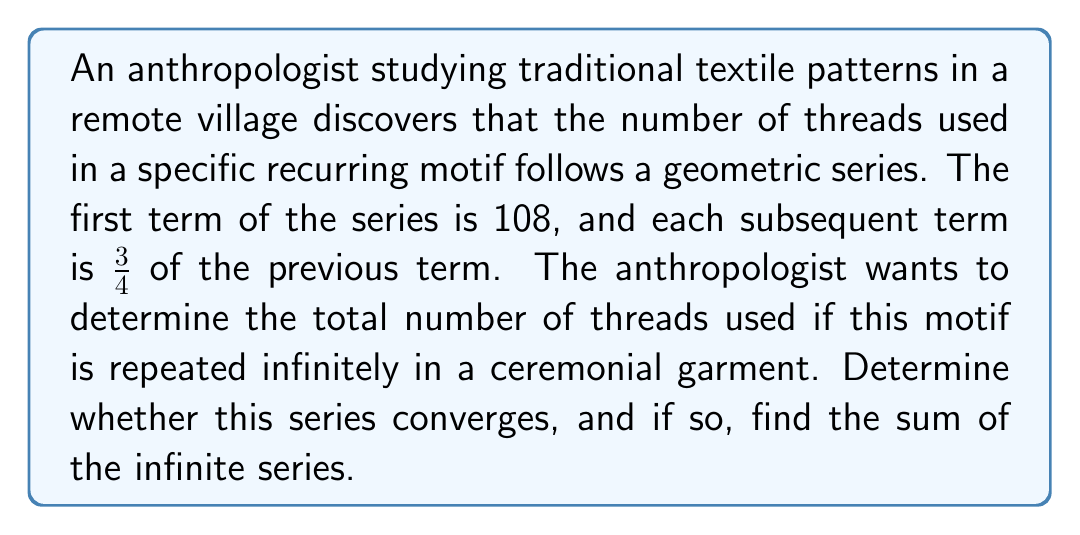Teach me how to tackle this problem. To analyze the convergence and sum of this infinite geometric series, we'll follow these steps:

1) First, let's identify the components of the geometric series:
   $a = 108$ (first term)
   $r = \frac{3}{4}$ (common ratio)

2) For a geometric series to converge, the absolute value of the common ratio must be less than 1:
   $|r| < 1$
   $|\frac{3}{4}| = \frac{3}{4} < 1$

   This condition is satisfied, so the series converges.

3) For a convergent geometric series, we can use the formula for the sum of an infinite geometric series:

   $$S_{\infty} = \frac{a}{1-r}$$

   Where $S_{\infty}$ is the sum of the infinite series, $a$ is the first term, and $r$ is the common ratio.

4) Let's substitute our values:

   $$S_{\infty} = \frac{108}{1-\frac{3}{4}}$$

5) Simplify:
   $$S_{\infty} = \frac{108}{\frac{1}{4}} = 108 \cdot 4 = 432$$

Therefore, the series converges to a sum of 432.

This result suggests that if the motif were to be repeated infinitely, it would use the equivalent of 432 threads. In practical terms for the anthropologist, this could represent the visual "weight" or prominence of this particular motif in the overall design of the ceremonial garment.
Answer: The series converges, and the sum of the infinite series is 432 threads. 